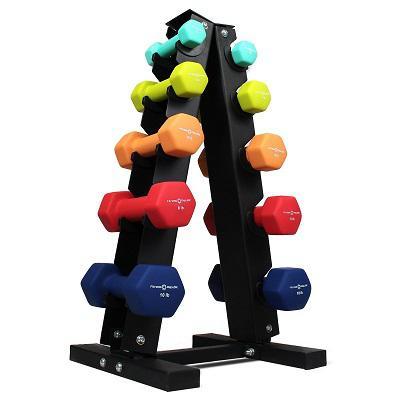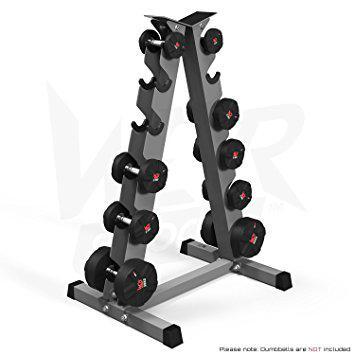The first image is the image on the left, the second image is the image on the right. Assess this claim about the two images: "There are two triangular shaped racks of dumbells in the pair of images.". Correct or not? Answer yes or no. Yes. The first image is the image on the left, the second image is the image on the right. Analyze the images presented: Is the assertion "Two metal racks for weights are trangular shaped, one of them black with various colored weights, the other gray with black weights." valid? Answer yes or no. Yes. 